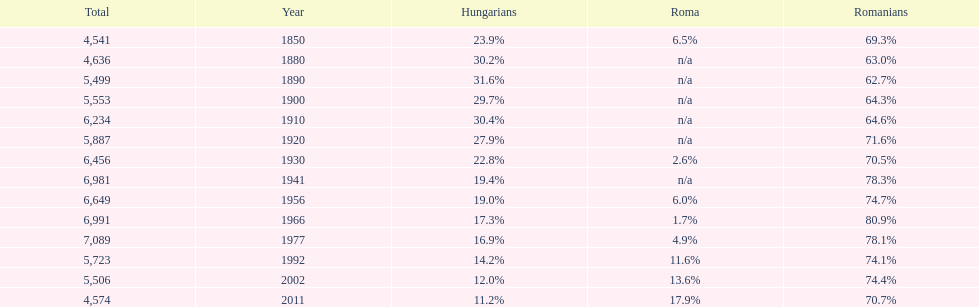What is the number of hungarians in 1850? 23.9%. 